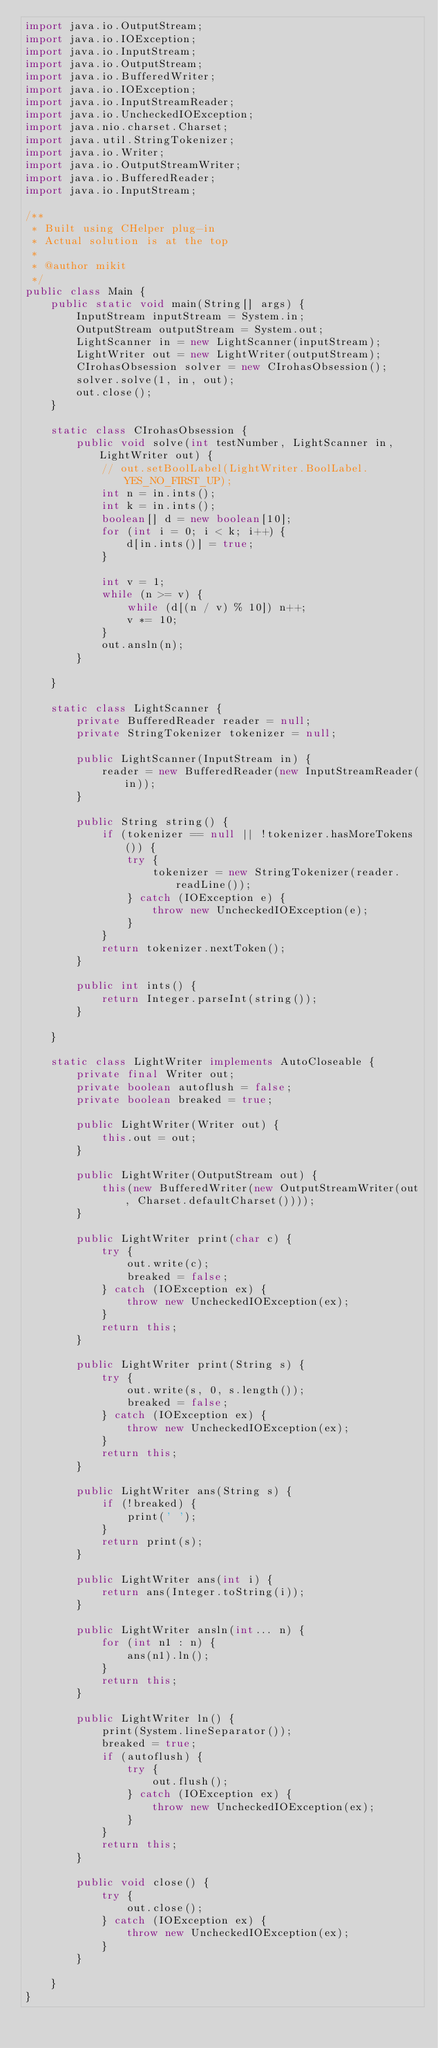<code> <loc_0><loc_0><loc_500><loc_500><_Java_>import java.io.OutputStream;
import java.io.IOException;
import java.io.InputStream;
import java.io.OutputStream;
import java.io.BufferedWriter;
import java.io.IOException;
import java.io.InputStreamReader;
import java.io.UncheckedIOException;
import java.nio.charset.Charset;
import java.util.StringTokenizer;
import java.io.Writer;
import java.io.OutputStreamWriter;
import java.io.BufferedReader;
import java.io.InputStream;

/**
 * Built using CHelper plug-in
 * Actual solution is at the top
 *
 * @author mikit
 */
public class Main {
    public static void main(String[] args) {
        InputStream inputStream = System.in;
        OutputStream outputStream = System.out;
        LightScanner in = new LightScanner(inputStream);
        LightWriter out = new LightWriter(outputStream);
        CIrohasObsession solver = new CIrohasObsession();
        solver.solve(1, in, out);
        out.close();
    }

    static class CIrohasObsession {
        public void solve(int testNumber, LightScanner in, LightWriter out) {
            // out.setBoolLabel(LightWriter.BoolLabel.YES_NO_FIRST_UP);
            int n = in.ints();
            int k = in.ints();
            boolean[] d = new boolean[10];
            for (int i = 0; i < k; i++) {
                d[in.ints()] = true;
            }

            int v = 1;
            while (n >= v) {
                while (d[(n / v) % 10]) n++;
                v *= 10;
            }
            out.ansln(n);
        }

    }

    static class LightScanner {
        private BufferedReader reader = null;
        private StringTokenizer tokenizer = null;

        public LightScanner(InputStream in) {
            reader = new BufferedReader(new InputStreamReader(in));
        }

        public String string() {
            if (tokenizer == null || !tokenizer.hasMoreTokens()) {
                try {
                    tokenizer = new StringTokenizer(reader.readLine());
                } catch (IOException e) {
                    throw new UncheckedIOException(e);
                }
            }
            return tokenizer.nextToken();
        }

        public int ints() {
            return Integer.parseInt(string());
        }

    }

    static class LightWriter implements AutoCloseable {
        private final Writer out;
        private boolean autoflush = false;
        private boolean breaked = true;

        public LightWriter(Writer out) {
            this.out = out;
        }

        public LightWriter(OutputStream out) {
            this(new BufferedWriter(new OutputStreamWriter(out, Charset.defaultCharset())));
        }

        public LightWriter print(char c) {
            try {
                out.write(c);
                breaked = false;
            } catch (IOException ex) {
                throw new UncheckedIOException(ex);
            }
            return this;
        }

        public LightWriter print(String s) {
            try {
                out.write(s, 0, s.length());
                breaked = false;
            } catch (IOException ex) {
                throw new UncheckedIOException(ex);
            }
            return this;
        }

        public LightWriter ans(String s) {
            if (!breaked) {
                print(' ');
            }
            return print(s);
        }

        public LightWriter ans(int i) {
            return ans(Integer.toString(i));
        }

        public LightWriter ansln(int... n) {
            for (int n1 : n) {
                ans(n1).ln();
            }
            return this;
        }

        public LightWriter ln() {
            print(System.lineSeparator());
            breaked = true;
            if (autoflush) {
                try {
                    out.flush();
                } catch (IOException ex) {
                    throw new UncheckedIOException(ex);
                }
            }
            return this;
        }

        public void close() {
            try {
                out.close();
            } catch (IOException ex) {
                throw new UncheckedIOException(ex);
            }
        }

    }
}

</code> 